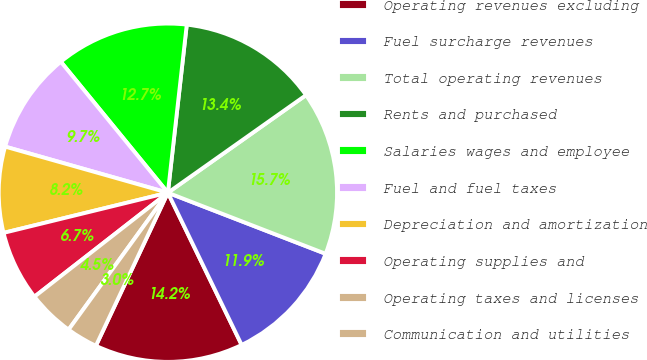<chart> <loc_0><loc_0><loc_500><loc_500><pie_chart><fcel>Operating revenues excluding<fcel>Fuel surcharge revenues<fcel>Total operating revenues<fcel>Rents and purchased<fcel>Salaries wages and employee<fcel>Fuel and fuel taxes<fcel>Depreciation and amortization<fcel>Operating supplies and<fcel>Operating taxes and licenses<fcel>Communication and utilities<nl><fcel>14.18%<fcel>11.94%<fcel>15.67%<fcel>13.43%<fcel>12.69%<fcel>9.7%<fcel>8.21%<fcel>6.72%<fcel>4.48%<fcel>2.99%<nl></chart> 